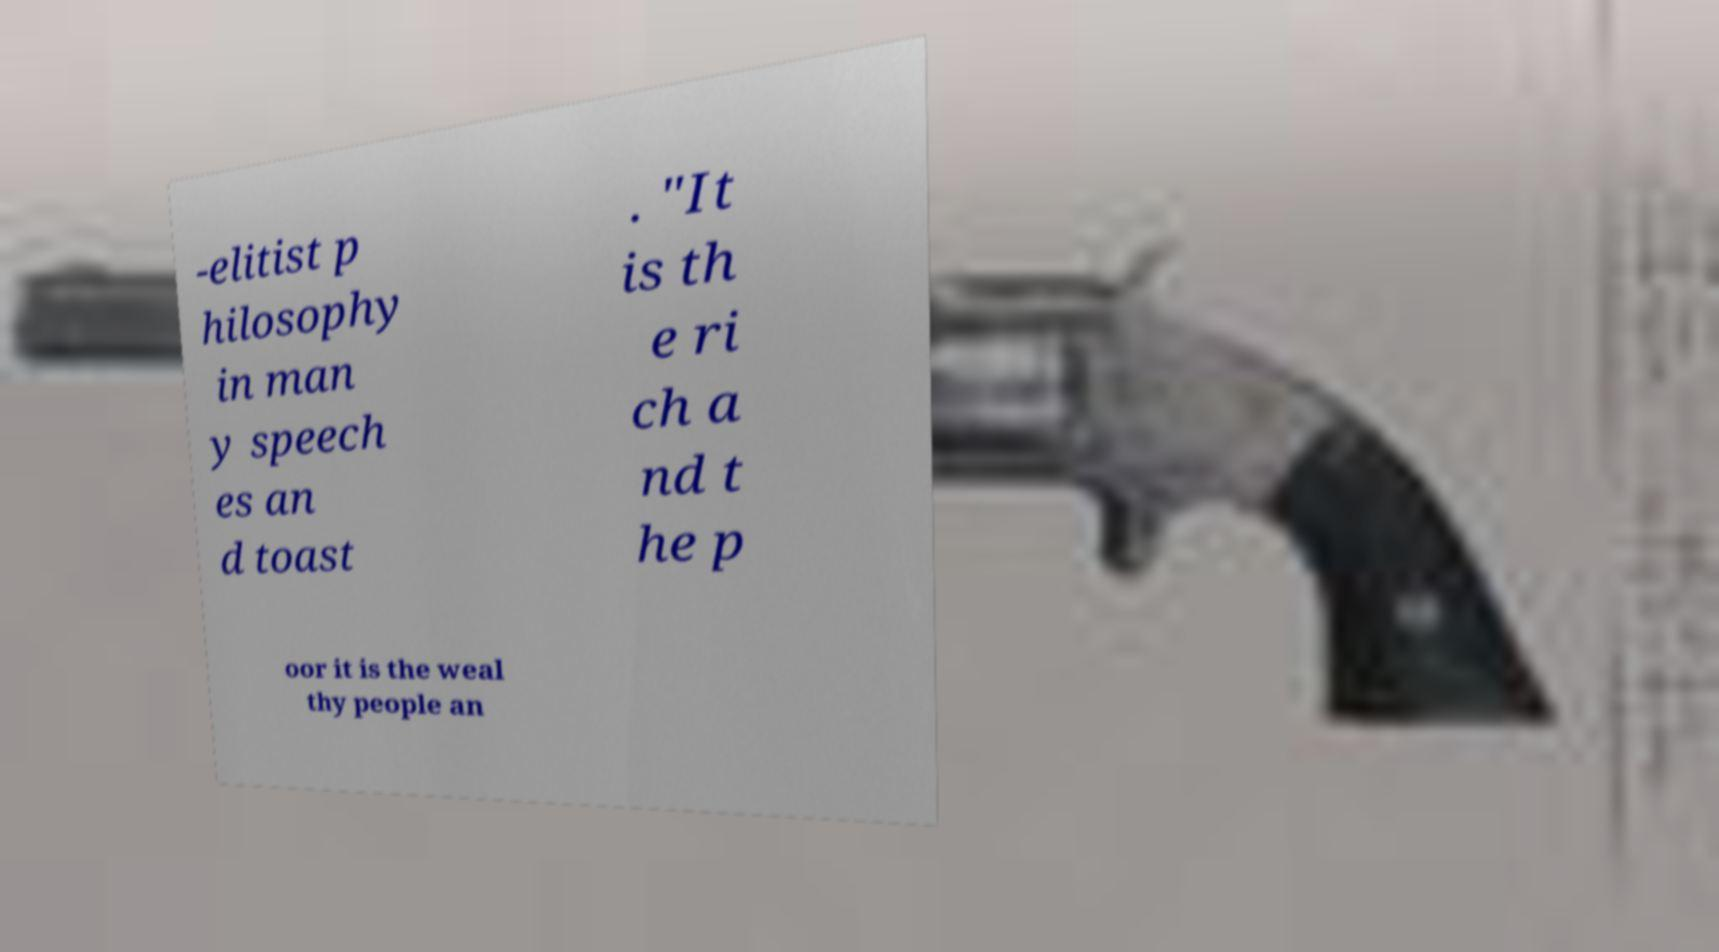Could you assist in decoding the text presented in this image and type it out clearly? -elitist p hilosophy in man y speech es an d toast . "It is th e ri ch a nd t he p oor it is the weal thy people an 